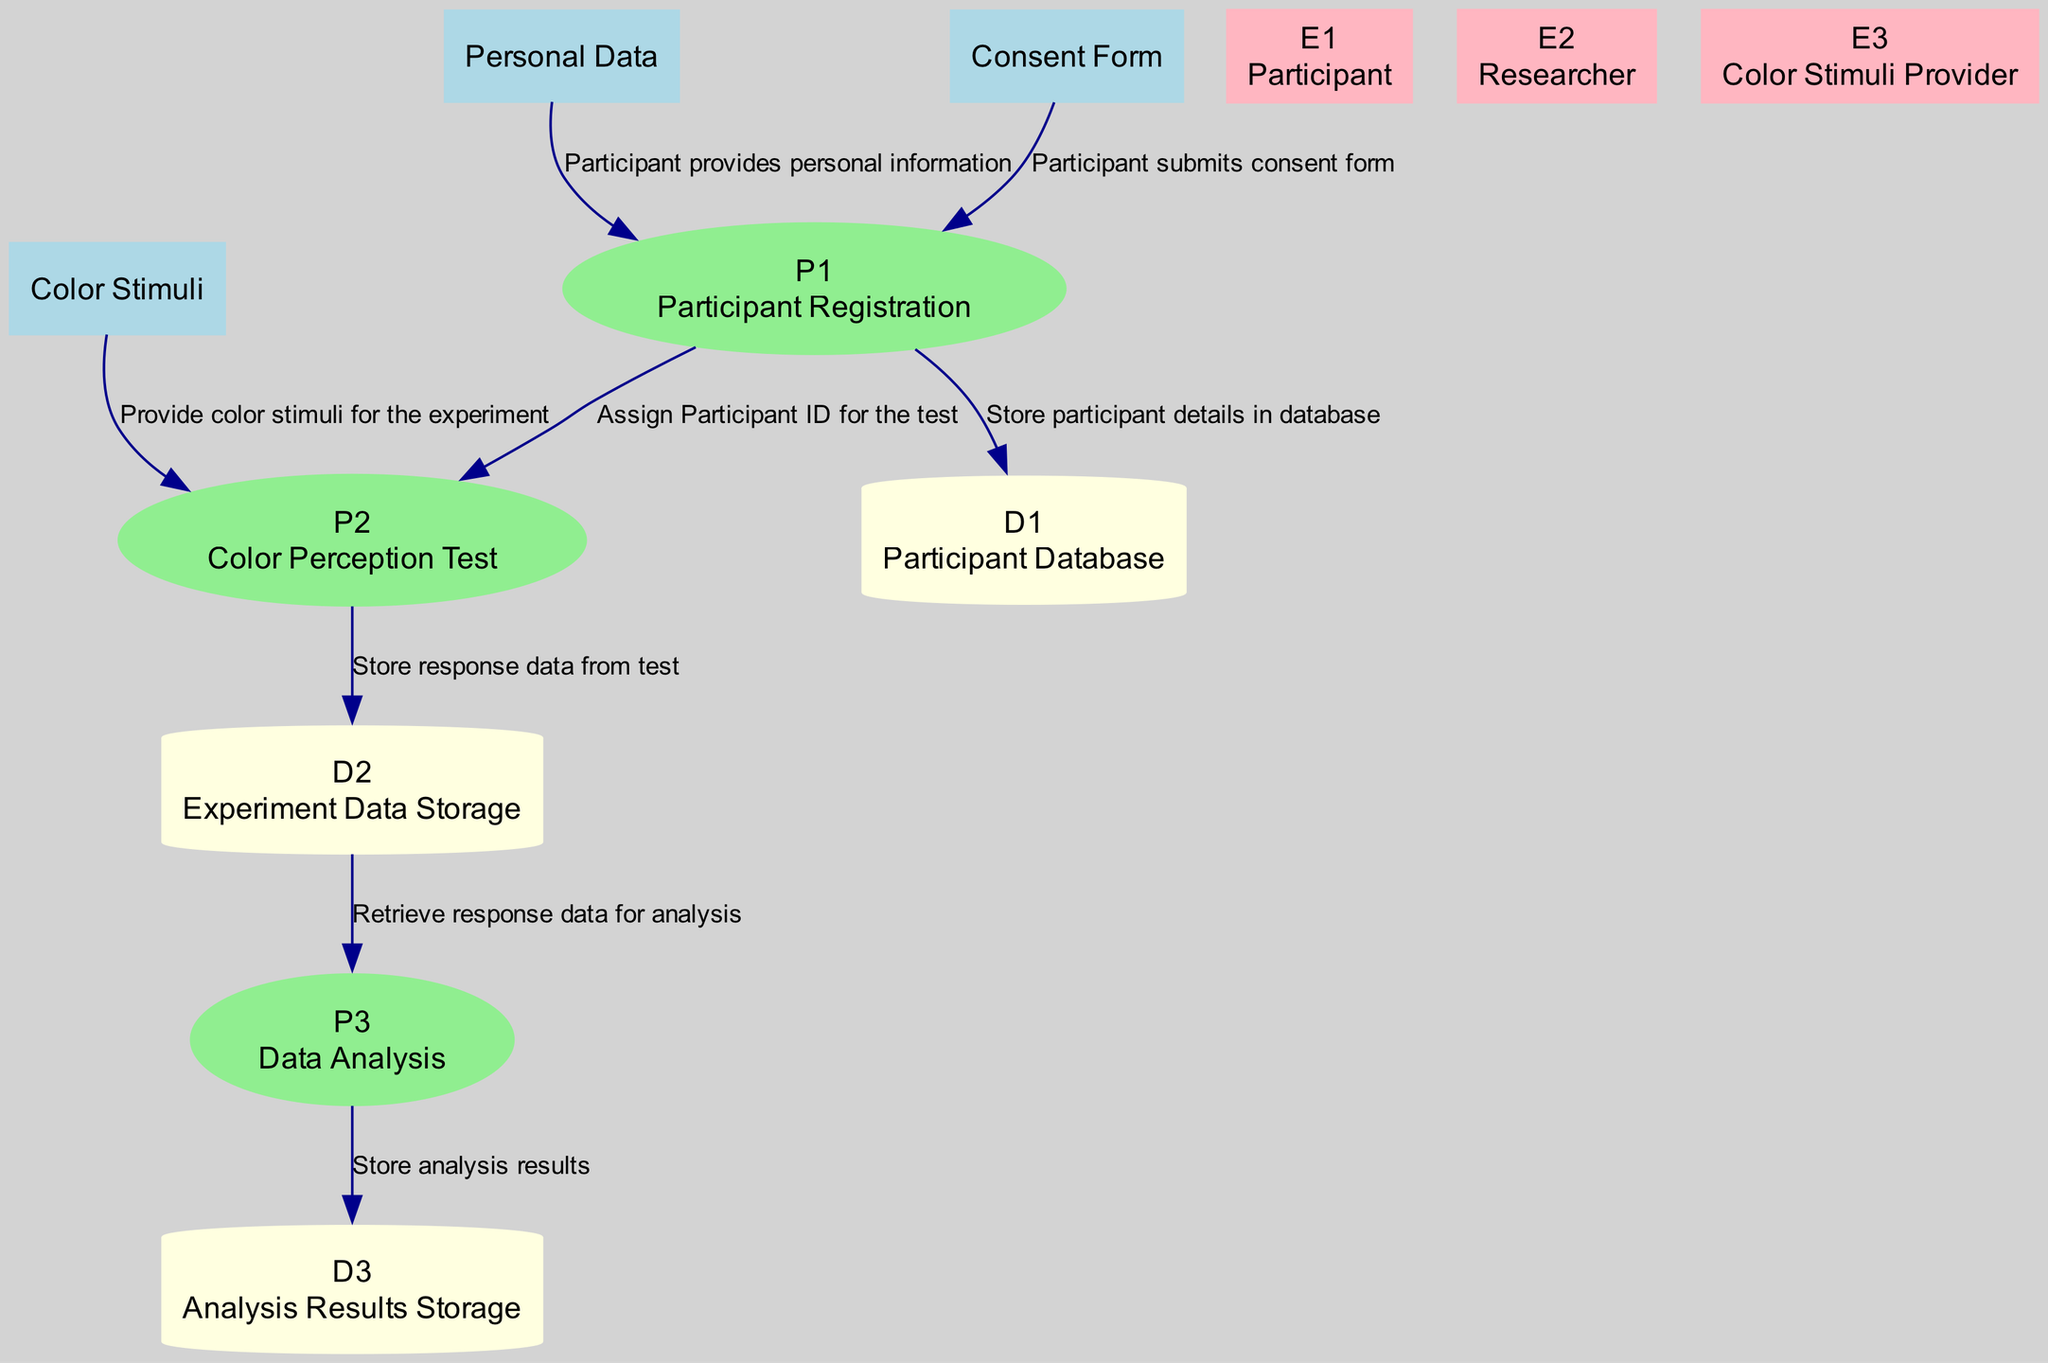What is the first process in the diagram? The first process in the diagram is labeled "P1" and is named "Participant Registration". It is the initial step where participant information and consent are collected.
Answer: Participant Registration How many data stores are present in the diagram? The diagram includes three data stores: "Participant Database", "Experiment Data Storage", and "Analysis Results Storage". By counting these, we find that there are three data stores in total.
Answer: 3 Which external entity provides consent in the experiment? The external entity that provides consent in the experiment is labeled "E1" and is named "Participant". This is the individual who supplies the necessary consent form and information.
Answer: Participant What is the output of the "Color Perception Test" process? The output of the "Color Perception Test" process, labeled "P2", is "Response Data". This is the data collected from the participant during the test, which will be analyzed later.
Answer: Response Data Which process retrieves data from the "Experiment Data Storage"? The process that retrieves data from the "Experiment Data Storage", which is labeled "D2", is "Data Analysis", identified as "P3". This step is crucial for understanding the results from the tests.
Answer: Data Analysis What flows from the "Color Stimuli" to "Color Perception Test"? The flow described as "F5" occurs from "Color Stimuli" to "Color Perception Test". This represents the provision of various color stimuli used in the test to assess participants' color perception.
Answer: Provide color stimuli Which data store receives outputs from the "Data Analysis" process? The data store that receives outputs from the "Data Analysis" process, represented as "P3", is "Analysis Results Storage", indicated as "D3". This is where the analyzed results are stored for future reference.
Answer: Analysis Results Storage How is participant information initially stored in the diagram? Participant information is initially stored in the "Participant Database", which is "D1". This step follows the participant registration process where details are collected and stored.
Answer: Participant Database What is the relationship between "Participant ID" and "Color Perception Test"? The "Participant ID" is an input for the "Color Perception Test" process, referred to as "P2". This means that the test requires the unique identifier to associate responses with the correct participant.
Answer: Input What does the "Data Analysis" process analyze? The "Data Analysis" process analyzes "Response Data", which is the data collected from the participants during the "Color Perception Test" labeled "P2". This step is critical for drawing conclusions about color perception.
Answer: Response Data 